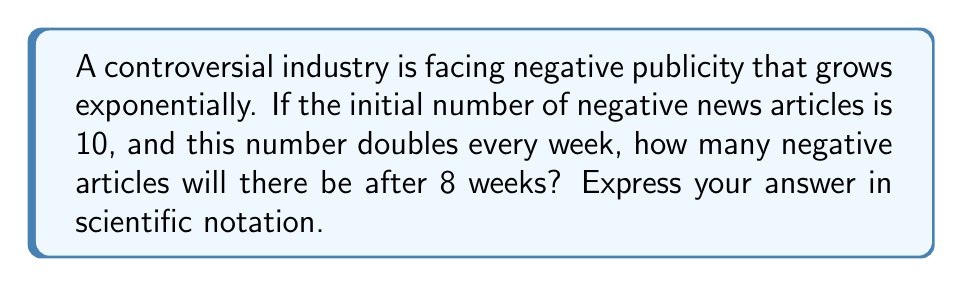Solve this math problem. Let's approach this step-by-step:

1) The initial number of articles is 10.

2) The number doubles every week, which means it's multiplied by 2 each week.

3) After 8 weeks, we need to multiply 10 by 2 eight times.

4) This can be expressed as an exponential equation:

   $10 \cdot 2^8$

5) Let's calculate $2^8$ first:
   $2^8 = 2 \cdot 2 \cdot 2 \cdot 2 \cdot 2 \cdot 2 \cdot 2 \cdot 2 = 256$

6) Now, we multiply this by our initial value:
   $10 \cdot 256 = 2560$

7) To express this in scientific notation, we move the decimal point to the left until we have a number between 1 and 10, and then count how many places we moved:

   $2560 = 2.56 \cdot 10^3$

Therefore, after 8 weeks, there will be $2.56 \cdot 10^3$ negative articles.
Answer: $2.56 \cdot 10^3$ 